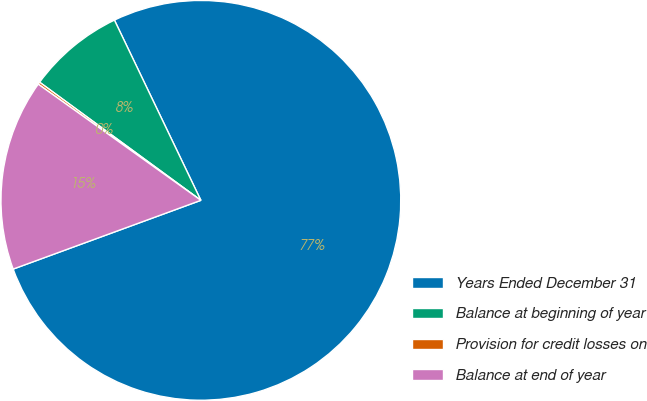<chart> <loc_0><loc_0><loc_500><loc_500><pie_chart><fcel>Years Ended December 31<fcel>Balance at beginning of year<fcel>Provision for credit losses on<fcel>Balance at end of year<nl><fcel>76.53%<fcel>7.82%<fcel>0.19%<fcel>15.46%<nl></chart> 